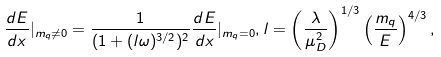<formula> <loc_0><loc_0><loc_500><loc_500>\frac { d E } { d x } | _ { m _ { q } \ne 0 } = \frac { 1 } { ( 1 + ( l \omega ) ^ { 3 / 2 } ) ^ { 2 } } \frac { d E } { d x } | _ { m _ { q } = 0 } , l = \left ( \frac { \lambda } { \mu _ { D } ^ { 2 } } \right ) ^ { 1 / 3 } \left ( \frac { m _ { q } } { E } \right ) ^ { 4 / 3 } ,</formula> 